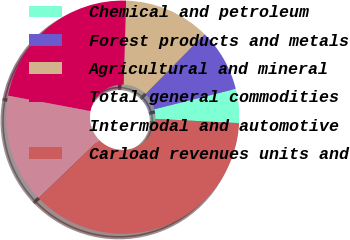<chart> <loc_0><loc_0><loc_500><loc_500><pie_chart><fcel>Chemical and petroleum<fcel>Forest products and metals<fcel>Agricultural and mineral<fcel>Total general commodities<fcel>Intermodal and automotive<fcel>Carload revenues units and<nl><fcel>4.73%<fcel>8.7%<fcel>11.92%<fcel>22.52%<fcel>15.15%<fcel>36.99%<nl></chart> 